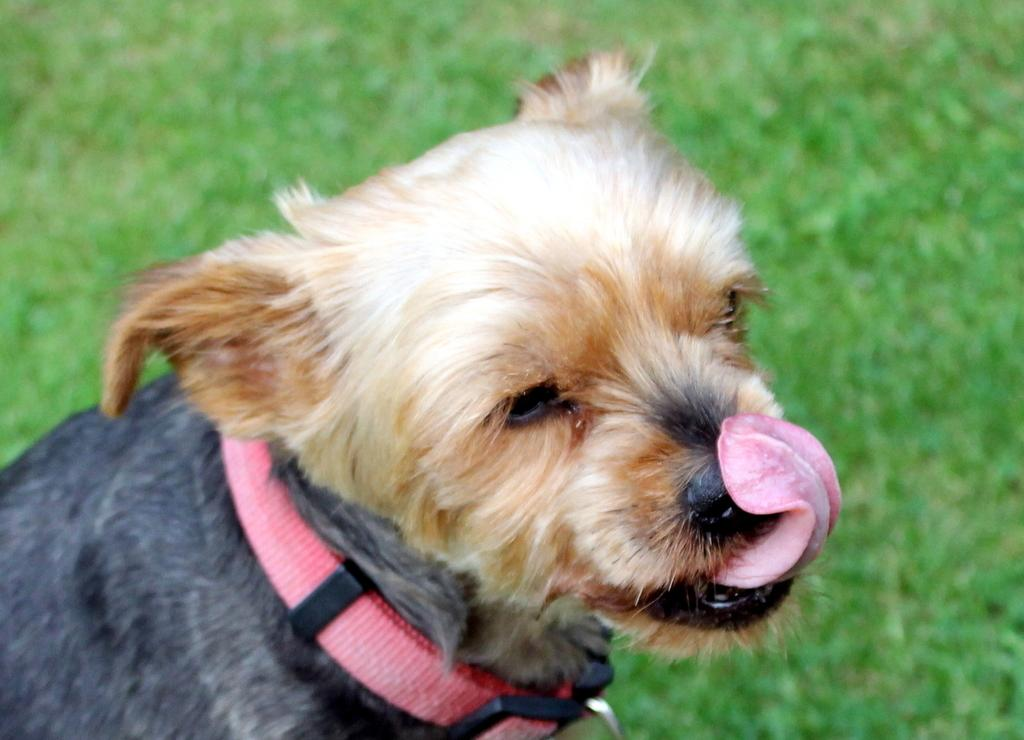What type of animal is in the image? There is a dog in the image. What is the dog wearing or holding in the image? The dog has a belt around its neck. What type of terrain is visible in the image? There is grass visible in the image. Can you see any wounds on the dog in the image? There is no indication of any wounds on the dog in the image. What type of doll is playing with the tiger in the image? There is no doll or tiger present in the image. 